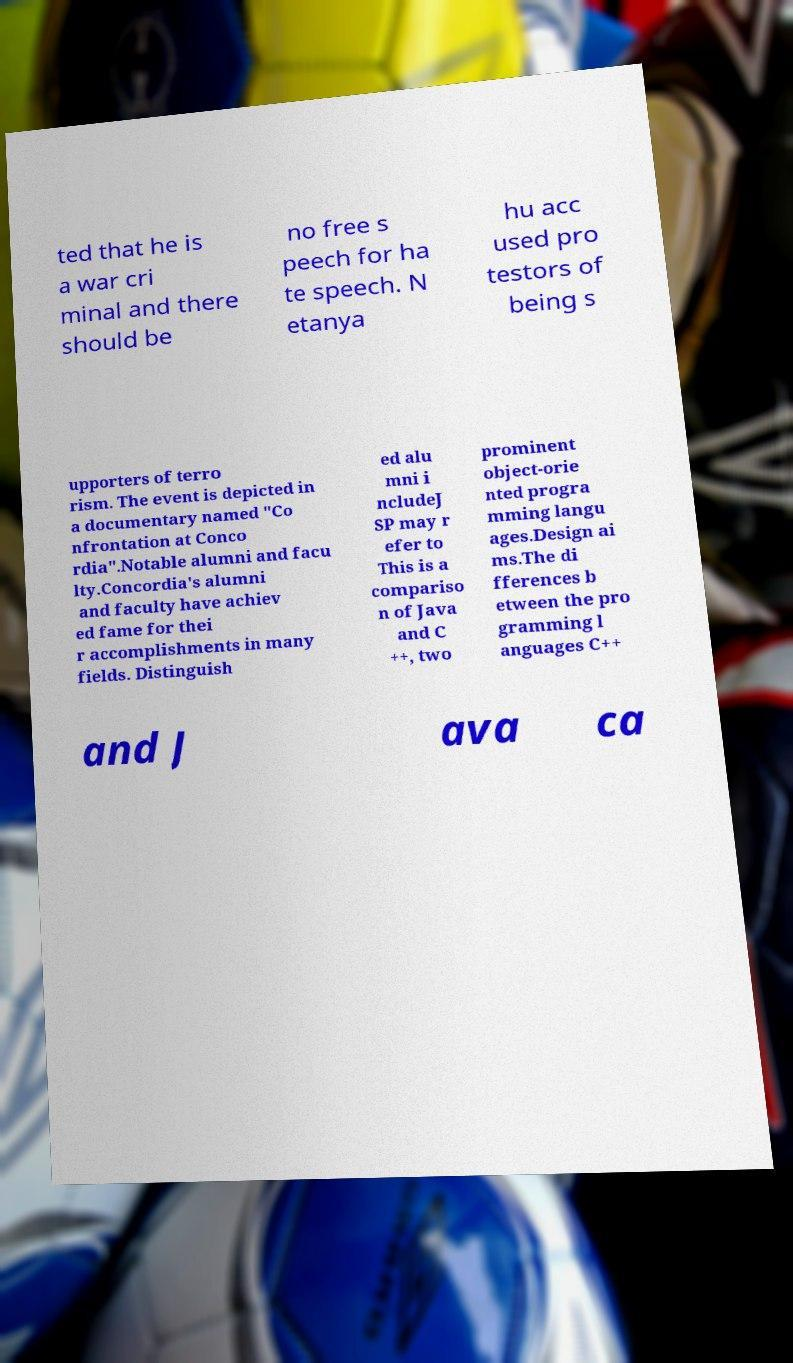Can you accurately transcribe the text from the provided image for me? ted that he is a war cri minal and there should be no free s peech for ha te speech. N etanya hu acc used pro testors of being s upporters of terro rism. The event is depicted in a documentary named "Co nfrontation at Conco rdia".Notable alumni and facu lty.Concordia's alumni and faculty have achiev ed fame for thei r accomplishments in many fields. Distinguish ed alu mni i ncludeJ SP may r efer to This is a compariso n of Java and C ++, two prominent object-orie nted progra mming langu ages.Design ai ms.The di fferences b etween the pro gramming l anguages C++ and J ava ca 